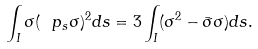Convert formula to latex. <formula><loc_0><loc_0><loc_500><loc_500>\int _ { I } \sigma ( \ p _ { s } \sigma ) ^ { 2 } d s = 3 \int _ { I } ( \sigma ^ { 2 } - \bar { \sigma } \sigma ) d s .</formula> 